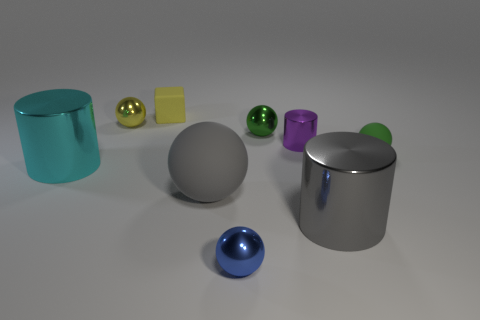The cylinder that is the same color as the big rubber object is what size?
Keep it short and to the point. Large. Are there the same number of gray balls that are in front of the large rubber ball and tiny yellow metallic balls?
Your answer should be very brief. No. How many spheres have the same color as the tiny matte cube?
Keep it short and to the point. 1. What color is the other big object that is the same shape as the cyan object?
Your response must be concise. Gray. Is the purple shiny cylinder the same size as the yellow cube?
Your response must be concise. Yes. Is the number of small rubber cubes in front of the big cyan shiny cylinder the same as the number of tiny blue metal spheres on the right side of the tiny blue sphere?
Your answer should be very brief. Yes. Is there a big yellow matte block?
Provide a succinct answer. No. What is the size of the green shiny thing that is the same shape as the yellow metallic thing?
Give a very brief answer. Small. There is a matte thing that is on the right side of the small blue object; what size is it?
Provide a short and direct response. Small. Are there more tiny objects that are behind the big cyan shiny cylinder than balls?
Ensure brevity in your answer.  No. 